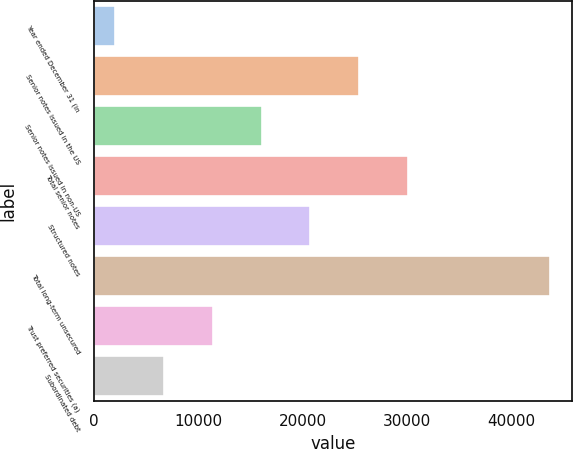<chart> <loc_0><loc_0><loc_500><loc_500><bar_chart><fcel>Year ended December 31 (in<fcel>Senior notes issued in the US<fcel>Senior notes issued in non-US<fcel>Total senior notes<fcel>Structured notes<fcel>Total long-term unsecured<fcel>Trust preferred securities (a)<fcel>Subordinated debt<nl><fcel>2013<fcel>25451<fcel>16075.8<fcel>30138.6<fcel>20763.4<fcel>43673<fcel>11388.2<fcel>6700.6<nl></chart> 